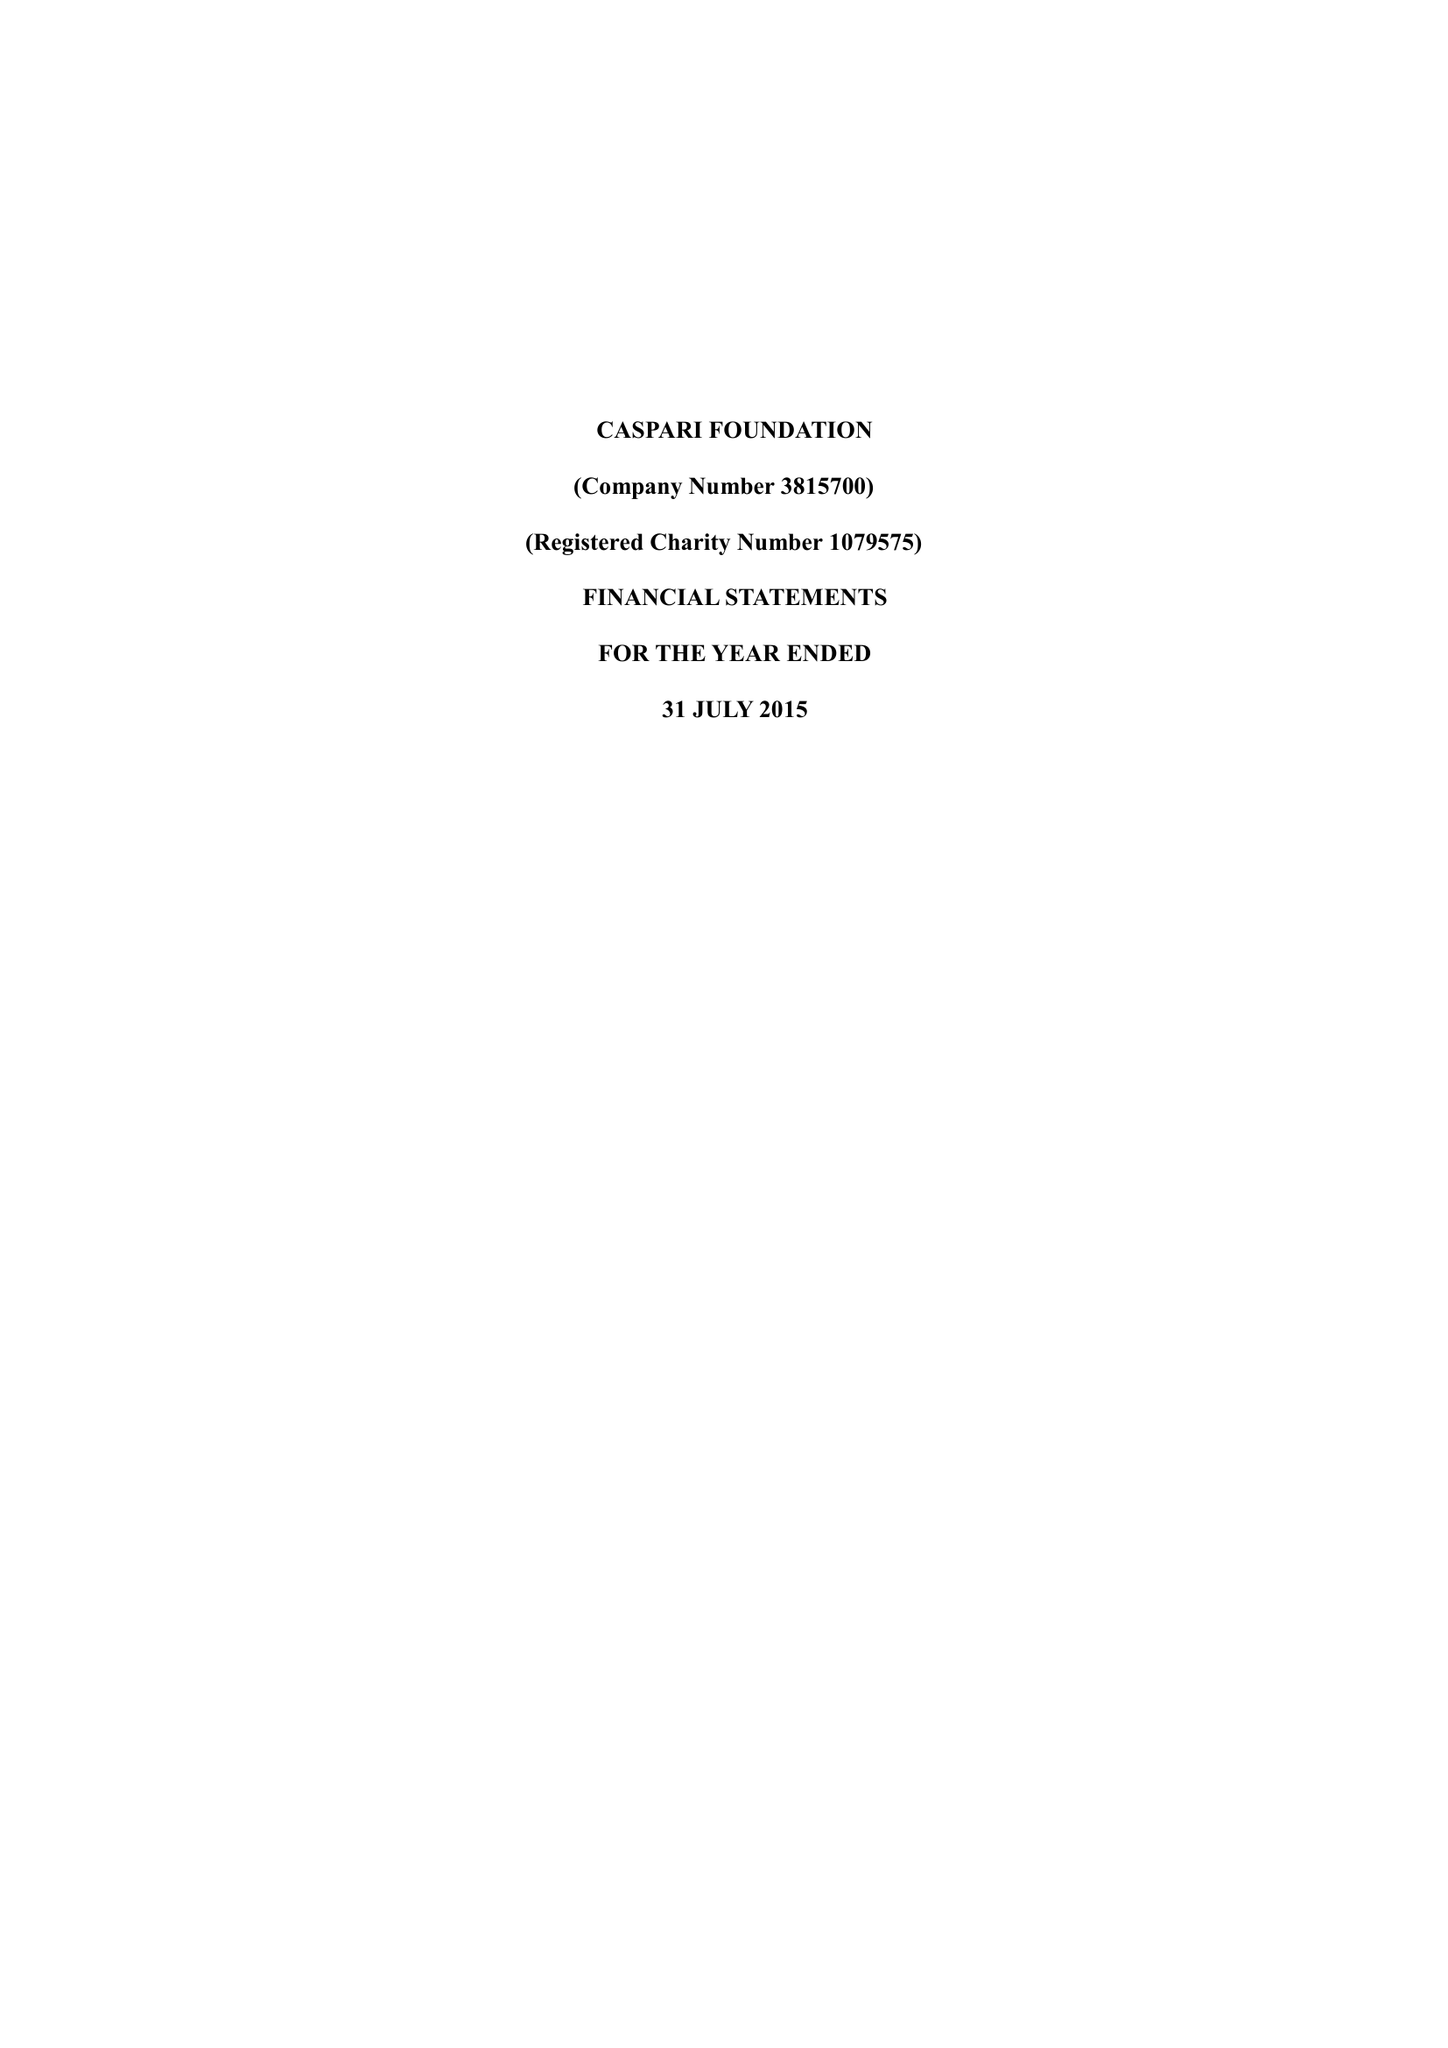What is the value for the spending_annually_in_british_pounds?
Answer the question using a single word or phrase. 144329.00 